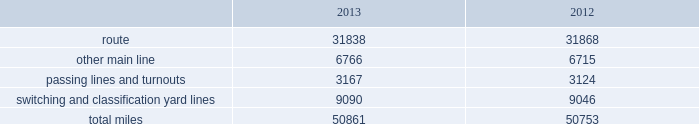Item 2 .
Properties we employ a variety of assets in the management and operation of our rail business .
Our rail network covers 23 states in the western two-thirds of the u.s .
Our rail network includes 31838 route miles .
We own 26009 miles and operate on the remainder pursuant to trackage rights or leases .
The table describes track miles at december 31 , 2013 and 2012 .
2013 2012 .
Headquarters building we maintain our headquarters in omaha , nebraska .
The facility has 1.2 million square feet of space for approximately 4000 employees and is subject to a financing arrangement .
Harriman dispatching center the harriman dispatching center ( hdc ) , located in omaha , nebraska , is our primary dispatching facility .
It is linked to regional dispatching and locomotive management facilities at various locations along our .
What percentage of total miles of track were switching and classification yard lines in 2012? 
Computations: (9046 / 50753)
Answer: 0.17824. 